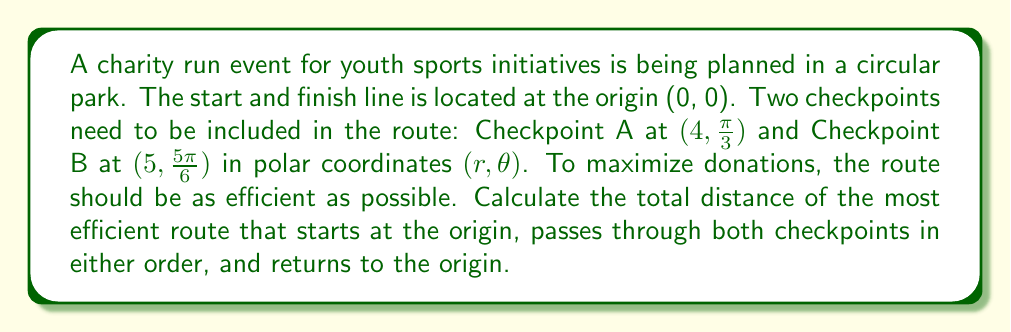Help me with this question. To solve this problem, we need to use the polar distance formula and compare the two possible routes:

1. Origin → A → B → Origin
2. Origin → B → A → Origin

Let's calculate each segment:

1. Distance from Origin to A:
   $d_{OA} = 4$ (given r value for A)

2. Distance from Origin to B:
   $d_{OB} = 5$ (given r value for B)

3. Distance from A to B:
   Using the polar distance formula: $d = \sqrt{r_1^2 + r_2^2 - 2r_1r_2\cos(\theta_2 - \theta_1)}$
   $d_{AB} = \sqrt{4^2 + 5^2 - 2(4)(5)\cos(\frac{5\pi}{6} - \frac{\pi}{3})}$
   $= \sqrt{16 + 25 - 40\cos(\frac{\pi}{2})}$
   $= \sqrt{41} \approx 6.403$ km

Now, let's calculate the total distance for each route:

Route 1: Origin → A → B → Origin
Total distance = $d_{OA} + d_{AB} + d_{OB} = 4 + \sqrt{41} + 5 \approx 15.403$ km

Route 2: Origin → B → A → Origin
Total distance = $d_{OB} + d_{AB} + d_{OA} = 5 + \sqrt{41} + 4 = 9 + \sqrt{41} \approx 15.403$ km

Both routes have the same total distance, so either can be chosen as the most efficient route.
Answer: The most efficient route distance is $9 + \sqrt{41} \approx 15.403$ km. 